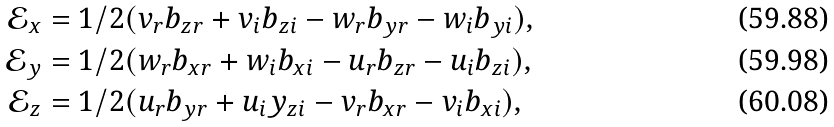Convert formula to latex. <formula><loc_0><loc_0><loc_500><loc_500>\mathcal { E } _ { x } & = 1 / 2 ( v _ { r } b _ { z r } + v _ { i } b _ { z i } - w _ { r } b _ { y r } - w _ { i } b _ { y i } ) , \\ \mathcal { E } _ { y } & = 1 / 2 ( w _ { r } b _ { x r } + w _ { i } b _ { x i } - u _ { r } b _ { z r } - u _ { i } b _ { z i } ) , \\ \mathcal { E } _ { z } & = 1 / 2 ( u _ { r } b _ { y r } + u _ { i } y _ { z i } - v _ { r } b _ { x r } - v _ { i } b _ { x i } ) ,</formula> 